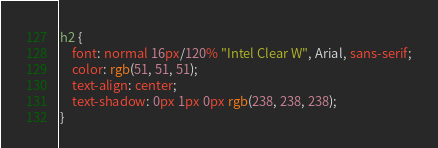<code> <loc_0><loc_0><loc_500><loc_500><_CSS_>
h2 {
    font: normal 16px/120% "Intel Clear W", Arial, sans-serif;
    color: rgb(51, 51, 51);
    text-align: center;
    text-shadow: 0px 1px 0px rgb(238, 238, 238);
}





































</code> 